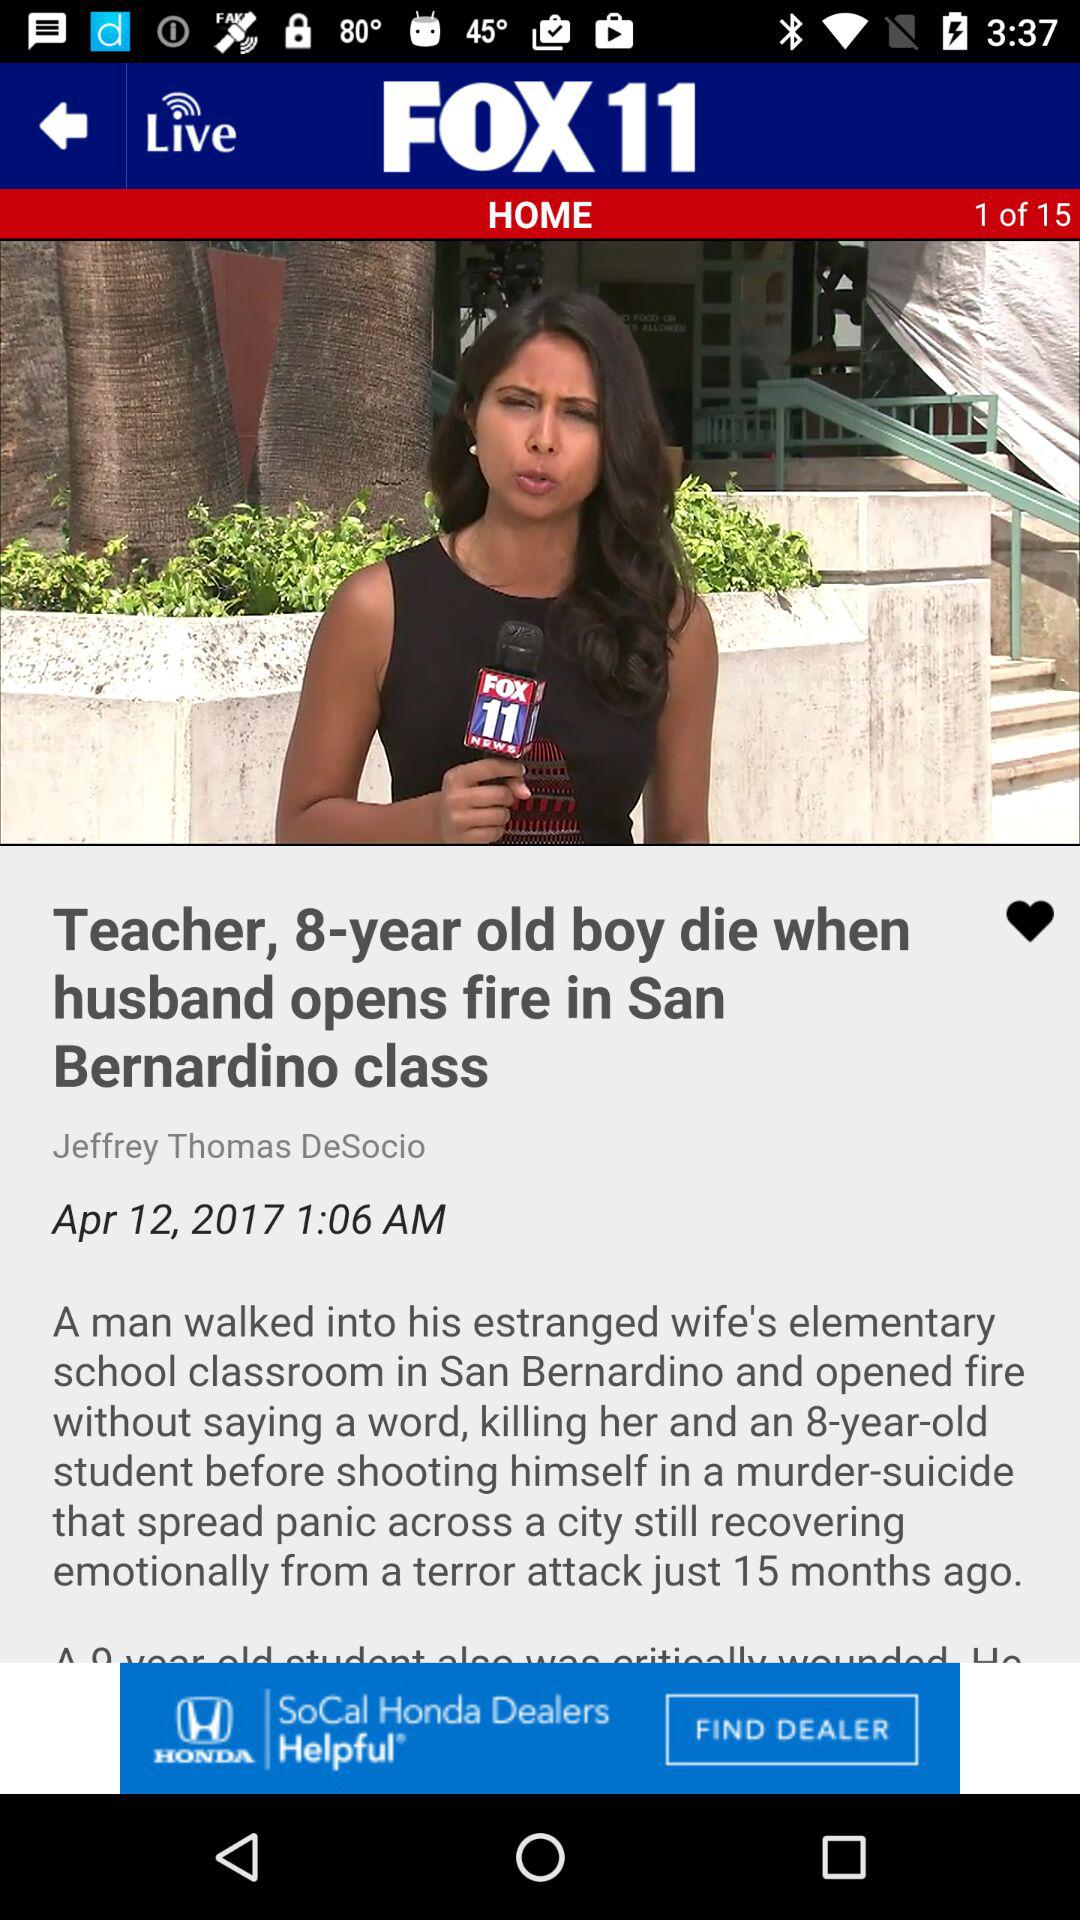Who posted the news "Teacher, 8-year old boy die when husband opens fire in San Bernardino class"? The news "Teacher, 8-year old boy die when husband opens fire in San Bernardino class" was posted by Jeffrey Thomas DeSocio. 